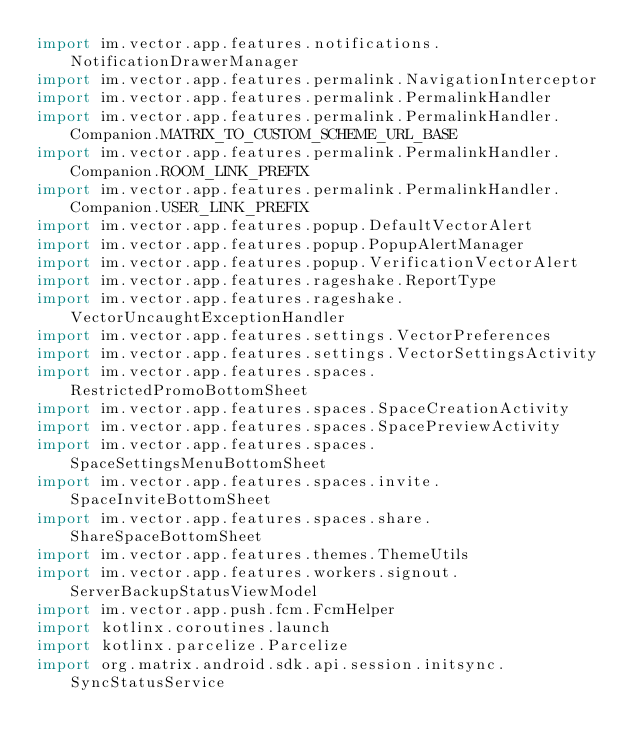Convert code to text. <code><loc_0><loc_0><loc_500><loc_500><_Kotlin_>import im.vector.app.features.notifications.NotificationDrawerManager
import im.vector.app.features.permalink.NavigationInterceptor
import im.vector.app.features.permalink.PermalinkHandler
import im.vector.app.features.permalink.PermalinkHandler.Companion.MATRIX_TO_CUSTOM_SCHEME_URL_BASE
import im.vector.app.features.permalink.PermalinkHandler.Companion.ROOM_LINK_PREFIX
import im.vector.app.features.permalink.PermalinkHandler.Companion.USER_LINK_PREFIX
import im.vector.app.features.popup.DefaultVectorAlert
import im.vector.app.features.popup.PopupAlertManager
import im.vector.app.features.popup.VerificationVectorAlert
import im.vector.app.features.rageshake.ReportType
import im.vector.app.features.rageshake.VectorUncaughtExceptionHandler
import im.vector.app.features.settings.VectorPreferences
import im.vector.app.features.settings.VectorSettingsActivity
import im.vector.app.features.spaces.RestrictedPromoBottomSheet
import im.vector.app.features.spaces.SpaceCreationActivity
import im.vector.app.features.spaces.SpacePreviewActivity
import im.vector.app.features.spaces.SpaceSettingsMenuBottomSheet
import im.vector.app.features.spaces.invite.SpaceInviteBottomSheet
import im.vector.app.features.spaces.share.ShareSpaceBottomSheet
import im.vector.app.features.themes.ThemeUtils
import im.vector.app.features.workers.signout.ServerBackupStatusViewModel
import im.vector.app.push.fcm.FcmHelper
import kotlinx.coroutines.launch
import kotlinx.parcelize.Parcelize
import org.matrix.android.sdk.api.session.initsync.SyncStatusService</code> 